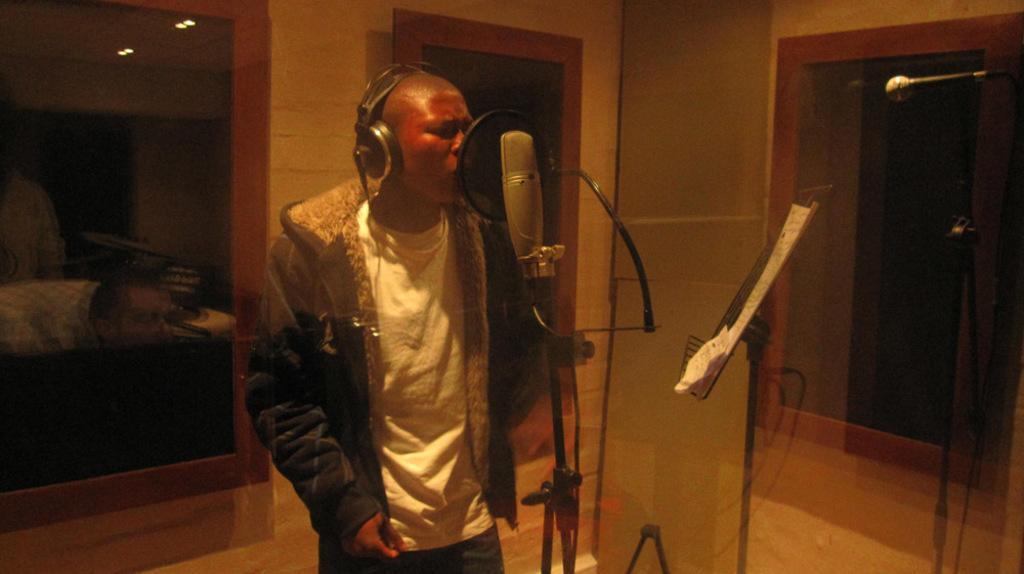In one or two sentences, can you explain what this image depicts? In the picture we can see a man standing in the recording theater and singing a song near the microphone stand, and he is with headsets and behind him we can see the wall with glasses to it. 